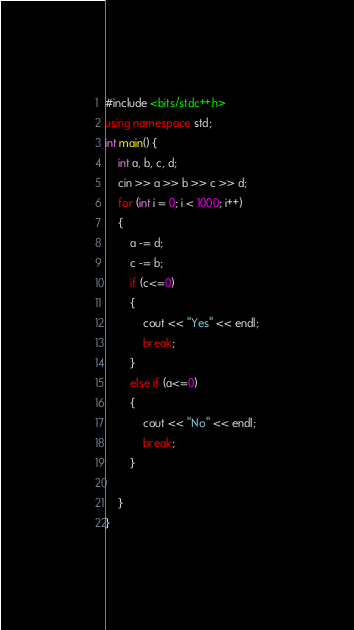<code> <loc_0><loc_0><loc_500><loc_500><_C++_>#include <bits/stdc++.h>
using namespace std;
int main() {
	int a, b, c, d;
	cin >> a >> b >> c >> d;
	for (int i = 0; i < 1000; i++)
	{
		a -= d;
		c -= b;
		if (c<=0)
		{
			cout << "Yes" << endl;
			break;
		}
		else if (a<=0)
		{
			cout << "No" << endl;
			break;
		}

	}
}</code> 